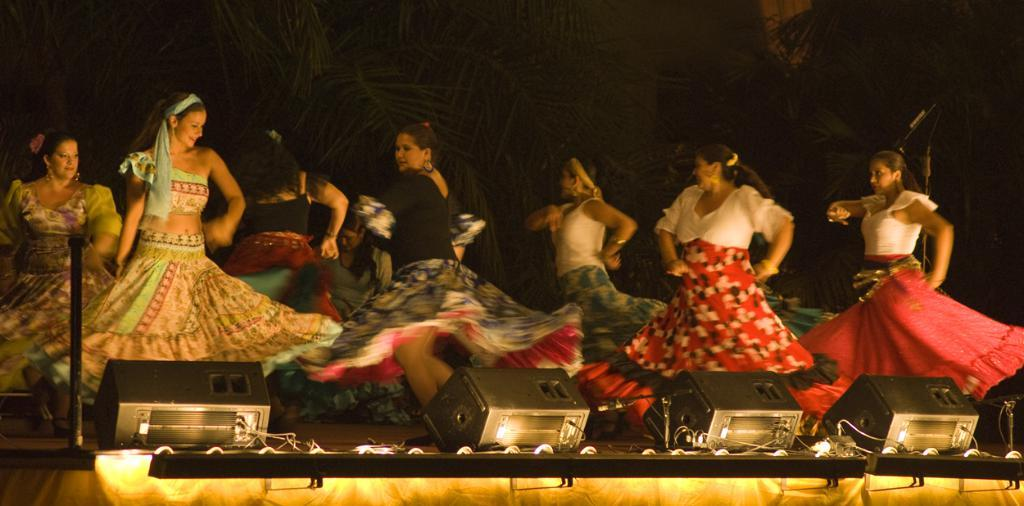What are the ladies in the image doing? The ladies in the center of the image are dancing. What can be found at the bottom of the image? There are speakers and lights at the bottom of the image. What is visible in the background of the image? There are trees in the background of the image. Can you see a quarter on the floor near the dancing ladies? There is no quarter visible on the floor near the dancing ladies in the image. 